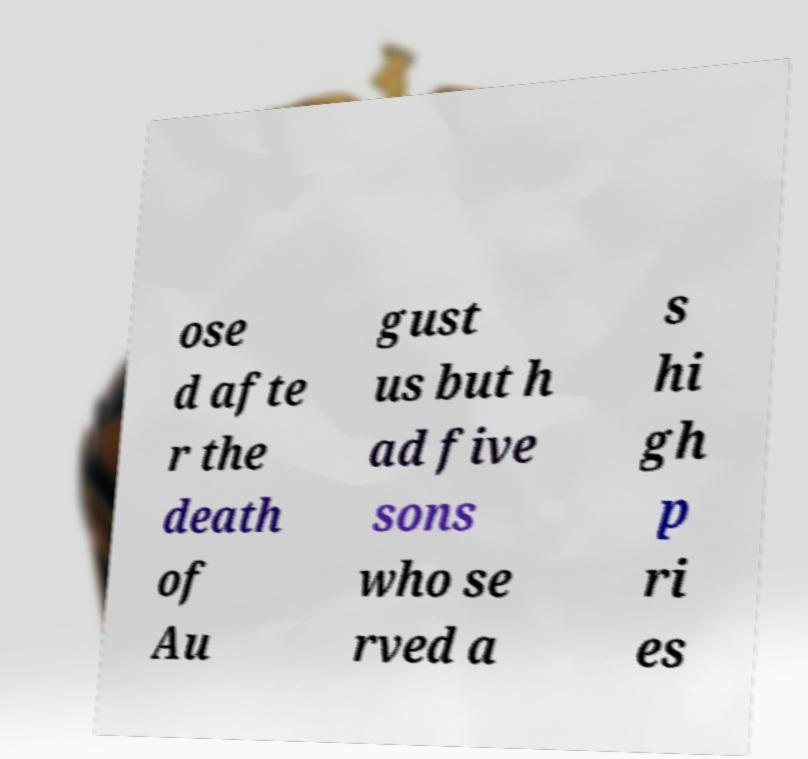There's text embedded in this image that I need extracted. Can you transcribe it verbatim? ose d afte r the death of Au gust us but h ad five sons who se rved a s hi gh p ri es 